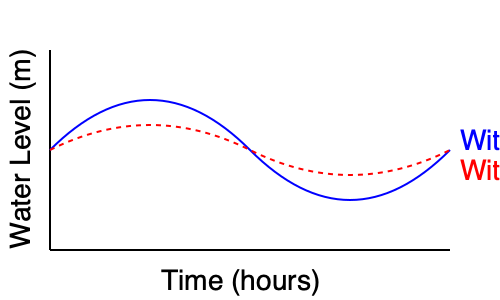Based on the graph showing water levels in the Venice lagoon over time, calculate the difference in tidal volume change between the scenarios with and without the Mose system activated. Assume the lagoon area is 550 km² and the tidal cycle lasts 12 hours. Express your answer in cubic meters. To solve this problem, we'll follow these steps:

1. Determine the maximum water level difference between the two scenarios:
   - Without Mose (blue line): Peak at approximately 1.5 m
   - With Mose (red line): Peak at approximately 1.0 m
   - Difference: 1.5 m - 1.0 m = 0.5 m

2. Calculate the area affected:
   - Given lagoon area = 550 km² = 550,000,000 m²

3. Calculate the volume difference:
   - Volume = Area × Height difference
   - Volume = 550,000,000 m² × 0.5 m = 275,000,000 m³

4. Consider that this volume difference occurs twice in a tidal cycle (once during high tide and once during low tide), so we double the result:
   - Total volume difference = 275,000,000 m³ × 2 = 550,000,000 m³

Therefore, the difference in tidal volume change between the scenarios with and without the Mose system activated is approximately 550,000,000 m³ per tidal cycle.
Answer: 550,000,000 m³ 